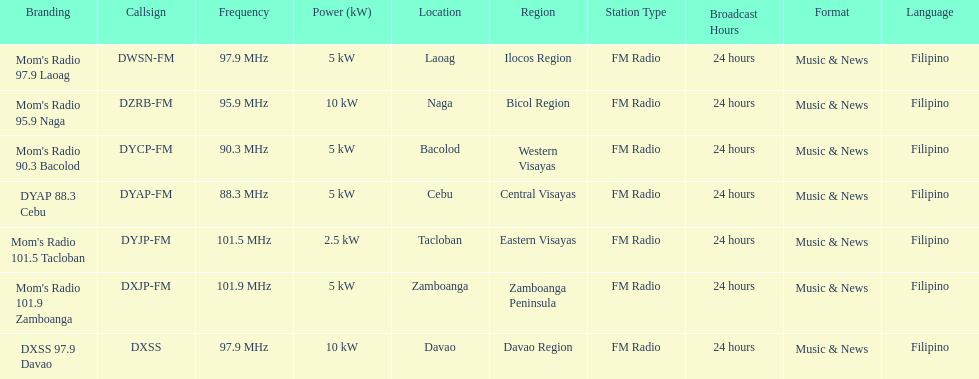How many times is the frequency greater than 95? 5. Help me parse the entirety of this table. {'header': ['Branding', 'Callsign', 'Frequency', 'Power (kW)', 'Location', 'Region', 'Station Type', 'Broadcast Hours', 'Format', 'Language'], 'rows': [["Mom's Radio 97.9 Laoag", 'DWSN-FM', '97.9\xa0MHz', '5\xa0kW', 'Laoag', 'Ilocos Region', 'FM Radio', '24 hours', 'Music & News', 'Filipino'], ["Mom's Radio 95.9 Naga", 'DZRB-FM', '95.9\xa0MHz', '10\xa0kW', 'Naga', 'Bicol Region', 'FM Radio', '24 hours', 'Music & News', 'Filipino'], ["Mom's Radio 90.3 Bacolod", 'DYCP-FM', '90.3\xa0MHz', '5\xa0kW', 'Bacolod', 'Western Visayas', 'FM Radio', '24 hours', 'Music & News', 'Filipino'], ['DYAP 88.3 Cebu', 'DYAP-FM', '88.3\xa0MHz', '5\xa0kW', 'Cebu', 'Central Visayas', 'FM Radio', '24 hours', 'Music & News', 'Filipino'], ["Mom's Radio 101.5 Tacloban", 'DYJP-FM', '101.5\xa0MHz', '2.5\xa0kW', 'Tacloban', 'Eastern Visayas', 'FM Radio', '24 hours', 'Music & News', 'Filipino'], ["Mom's Radio 101.9 Zamboanga", 'DXJP-FM', '101.9\xa0MHz', '5\xa0kW', 'Zamboanga', 'Zamboanga Peninsula', 'FM Radio', '24 hours', 'Music & News', 'Filipino'], ['DXSS 97.9 Davao', 'DXSS', '97.9\xa0MHz', '10\xa0kW', 'Davao', 'Davao Region', 'FM Radio', '24 hours', 'Music & News', 'Filipino']]} 